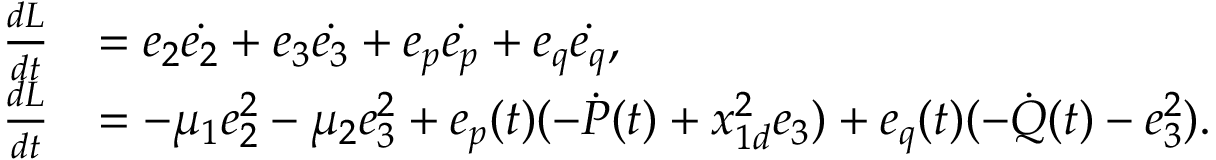<formula> <loc_0><loc_0><loc_500><loc_500>\begin{array} { l l } { \frac { d { L } } { d { t } } } & { = { { e } _ { 2 } } { \dot { { e } _ { 2 } } } + { { e } _ { 3 } } { \dot { { e } _ { 3 } } } + { { e } _ { p } } { \dot { { e } _ { p } } } + { { e } _ { q } } { \dot { { e } _ { q } } } , } \\ { \frac { d { L } } { d { t } } } & { = - { \mu } _ { 1 } e _ { 2 } ^ { 2 } - { \mu } _ { 2 } e _ { 3 } ^ { 2 } + { e } _ { p } ( t ) ( - \dot { P } ( t ) + { x } _ { 1 d } ^ { 2 } { e } _ { 3 } ) + { e _ { q } ( t ) } ( - \dot { Q } ( t ) - { e } _ { 3 } ^ { 2 } ) . } \end{array}</formula> 